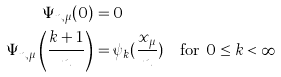<formula> <loc_0><loc_0><loc_500><loc_500>\Psi _ { n , \mu } ( 0 ) & = 0 \\ \Psi _ { n , \mu } \left ( \frac { k + 1 } { n } \right ) & = \psi _ { k } ( \frac { x _ { \mu } } n ) \quad \text {for $0\leq k < \infty$}</formula> 